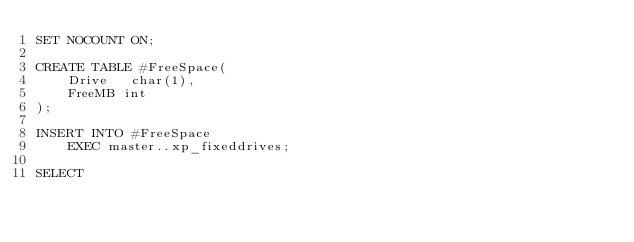Convert code to text. <code><loc_0><loc_0><loc_500><loc_500><_SQL_>SET NOCOUNT ON;

CREATE TABLE #FreeSpace(
    Drive   char(1), 
    FreeMB int
);

INSERT INTO #FreeSpace
    EXEC master..xp_fixeddrives;

SELECT </code> 